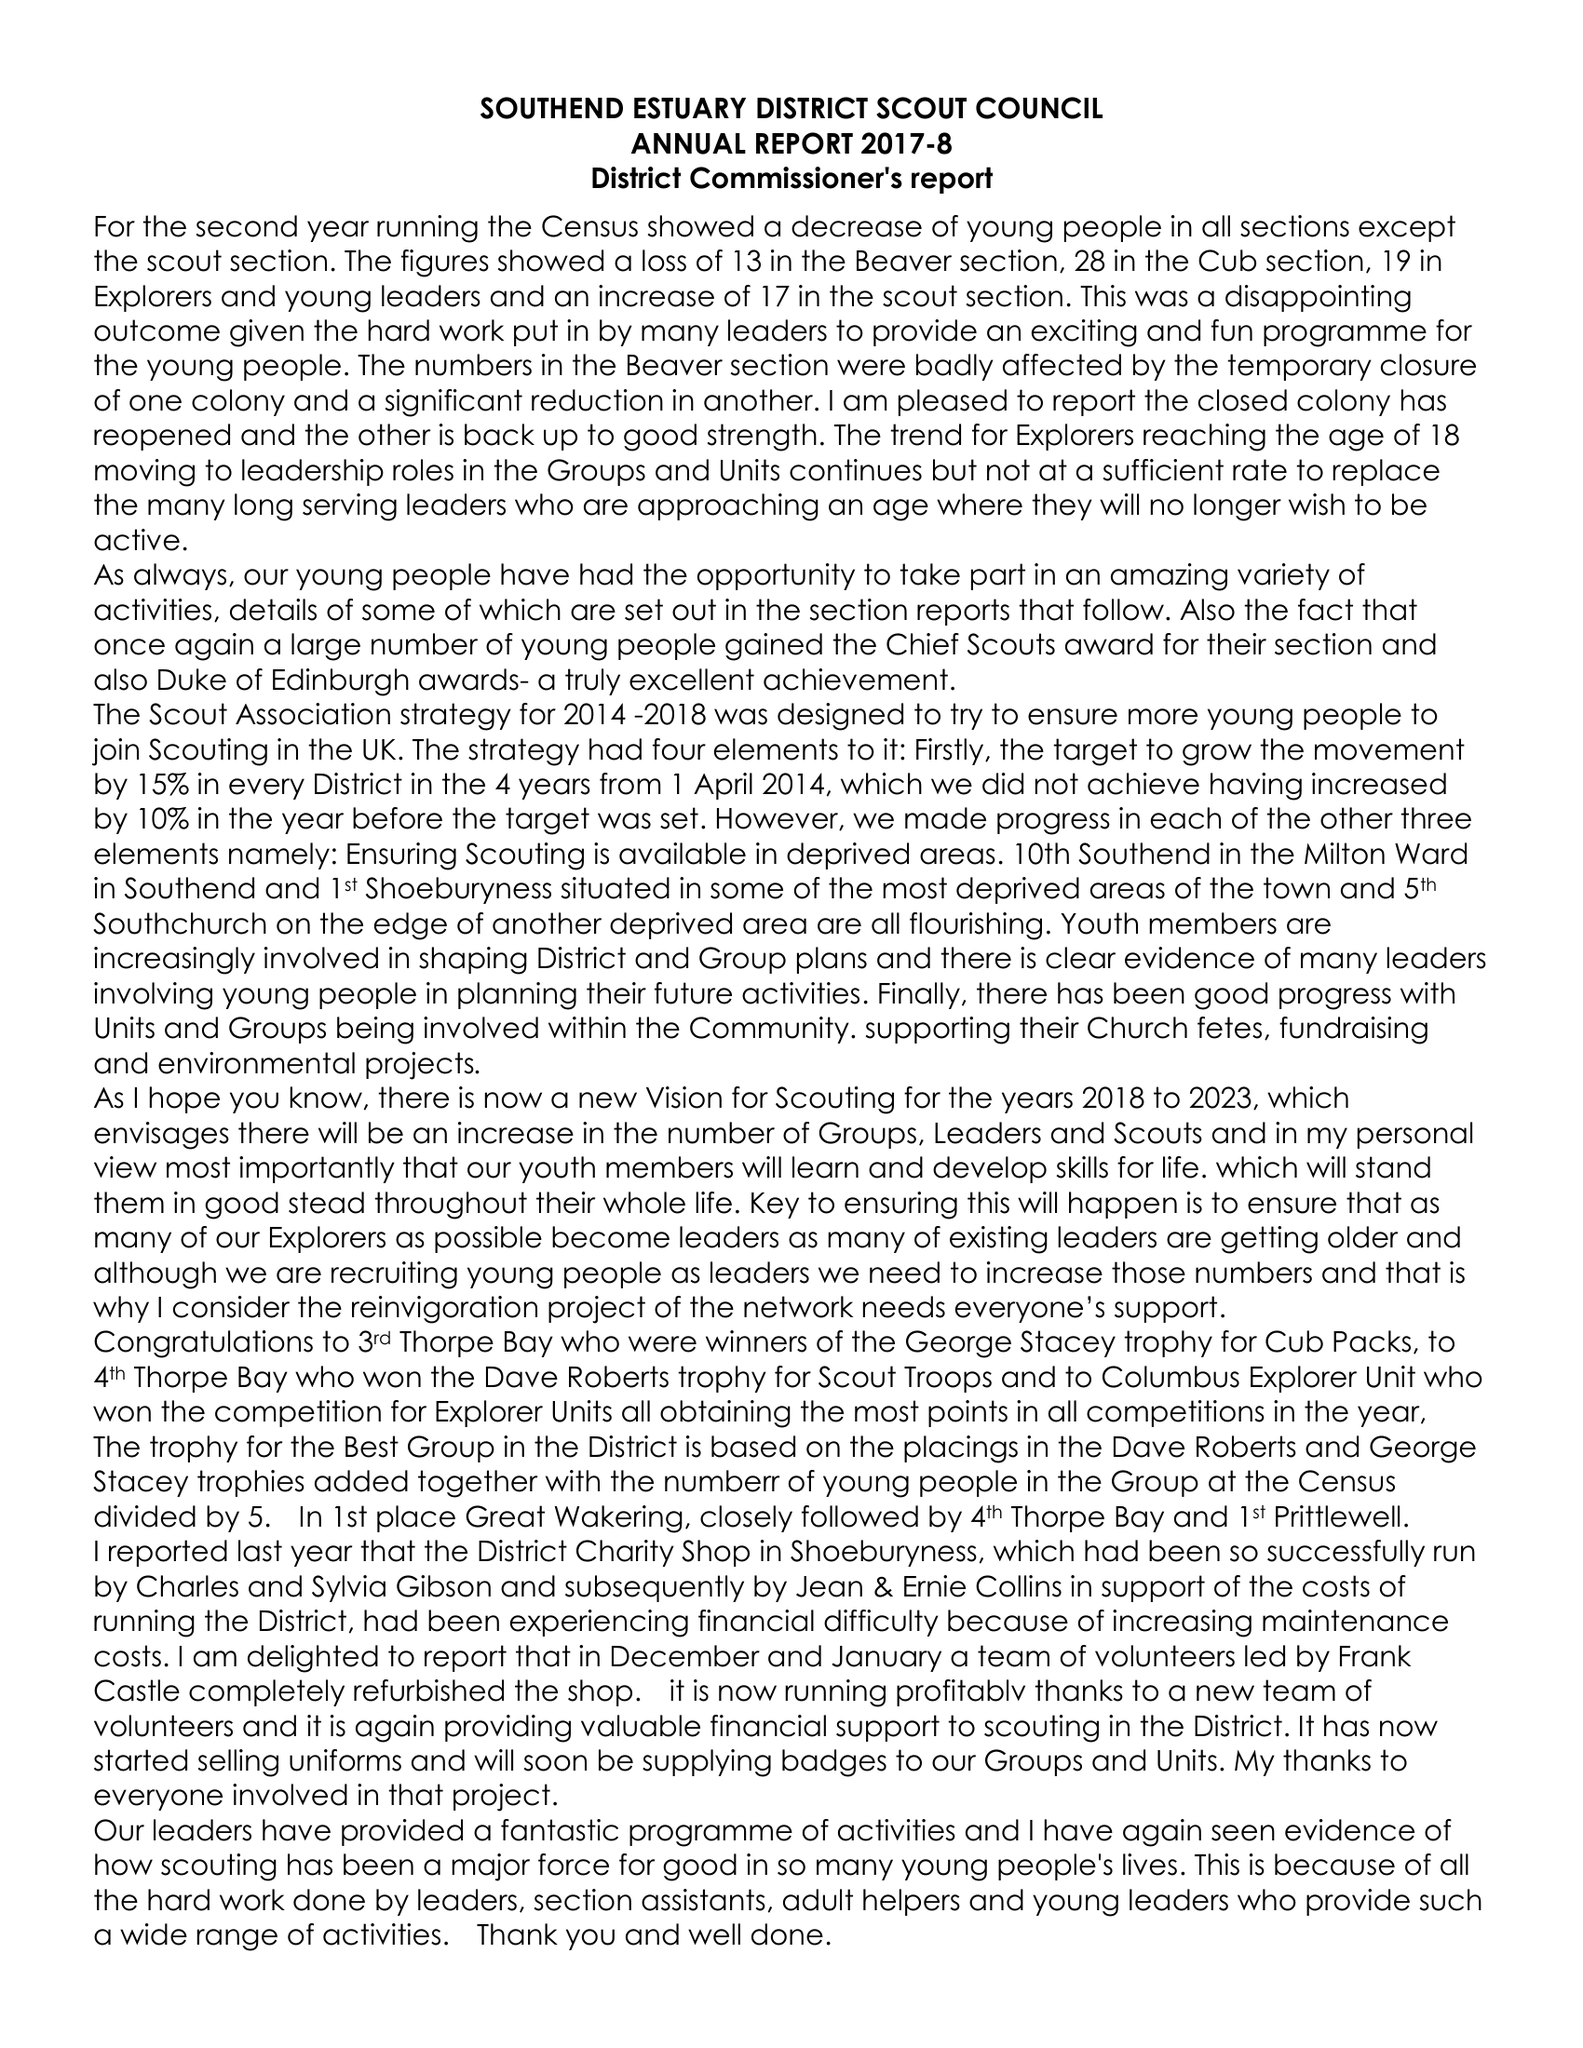What is the value for the charity_number?
Answer the question using a single word or phrase. 1045298 